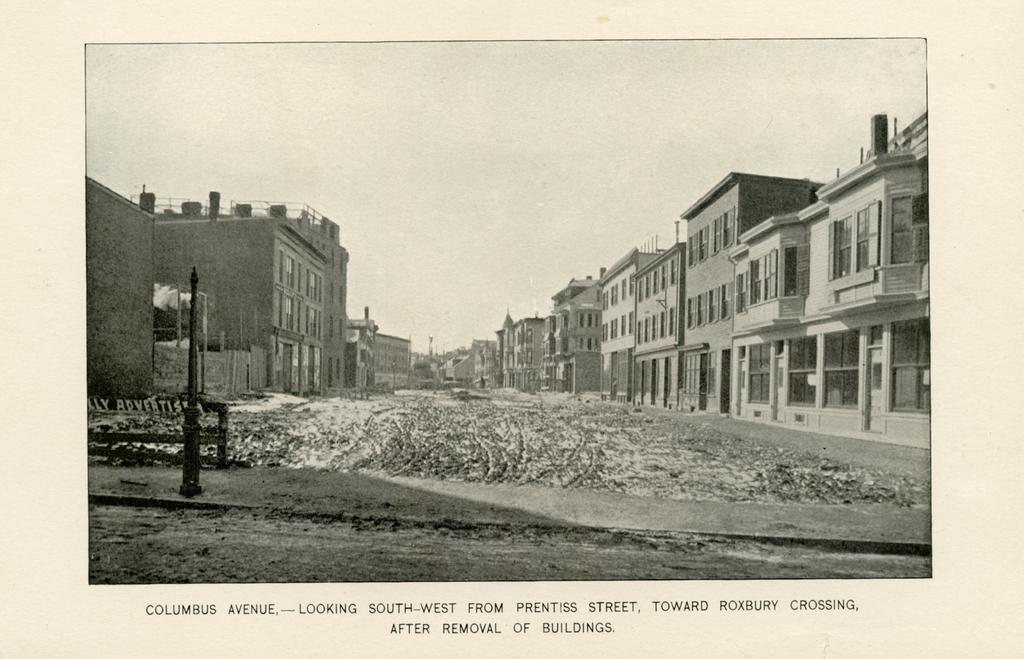Describe this image in one or two sentences. In this picture I can see in the middle there is the road, there are buildings on either side, at the bottom there is the text. At the top there is the sky, this image is in black and white color. 